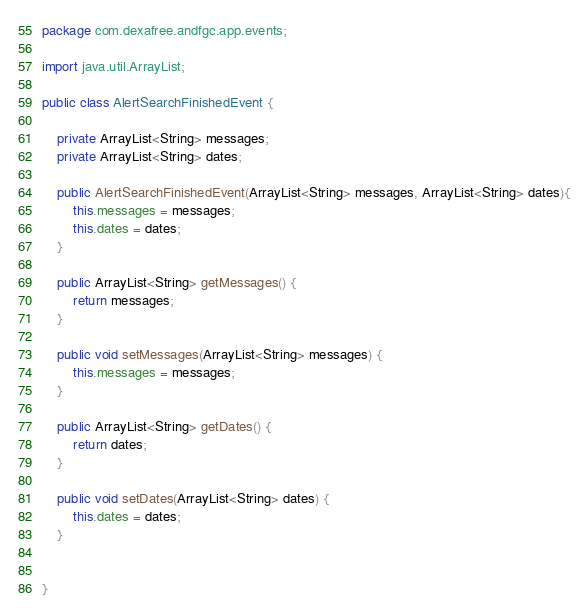Convert code to text. <code><loc_0><loc_0><loc_500><loc_500><_Java_>package com.dexafree.andfgc.app.events;

import java.util.ArrayList;

public class AlertSearchFinishedEvent {

    private ArrayList<String> messages;
    private ArrayList<String> dates;

    public AlertSearchFinishedEvent(ArrayList<String> messages, ArrayList<String> dates){
        this.messages = messages;
        this.dates = dates;
    }

    public ArrayList<String> getMessages() {
        return messages;
    }

    public void setMessages(ArrayList<String> messages) {
        this.messages = messages;
    }

    public ArrayList<String> getDates() {
        return dates;
    }

    public void setDates(ArrayList<String> dates) {
        this.dates = dates;
    }


}
</code> 